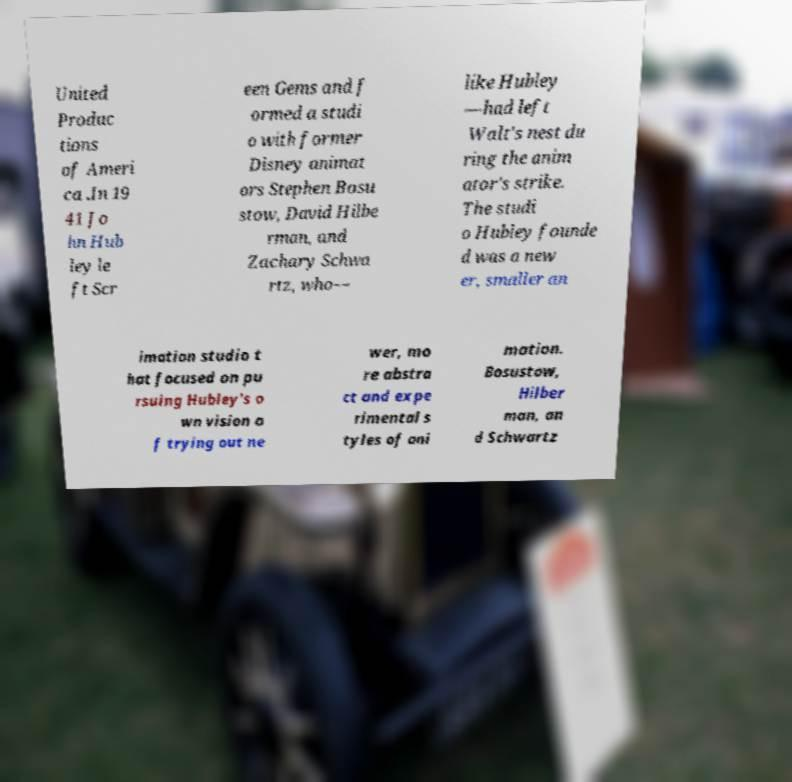Please read and relay the text visible in this image. What does it say? United Produc tions of Ameri ca .In 19 41 Jo hn Hub ley le ft Scr een Gems and f ormed a studi o with former Disney animat ors Stephen Bosu stow, David Hilbe rman, and Zachary Schwa rtz, who— like Hubley —had left Walt's nest du ring the anim ator's strike. The studi o Hubley founde d was a new er, smaller an imation studio t hat focused on pu rsuing Hubley's o wn vision o f trying out ne wer, mo re abstra ct and expe rimental s tyles of ani mation. Bosustow, Hilber man, an d Schwartz 